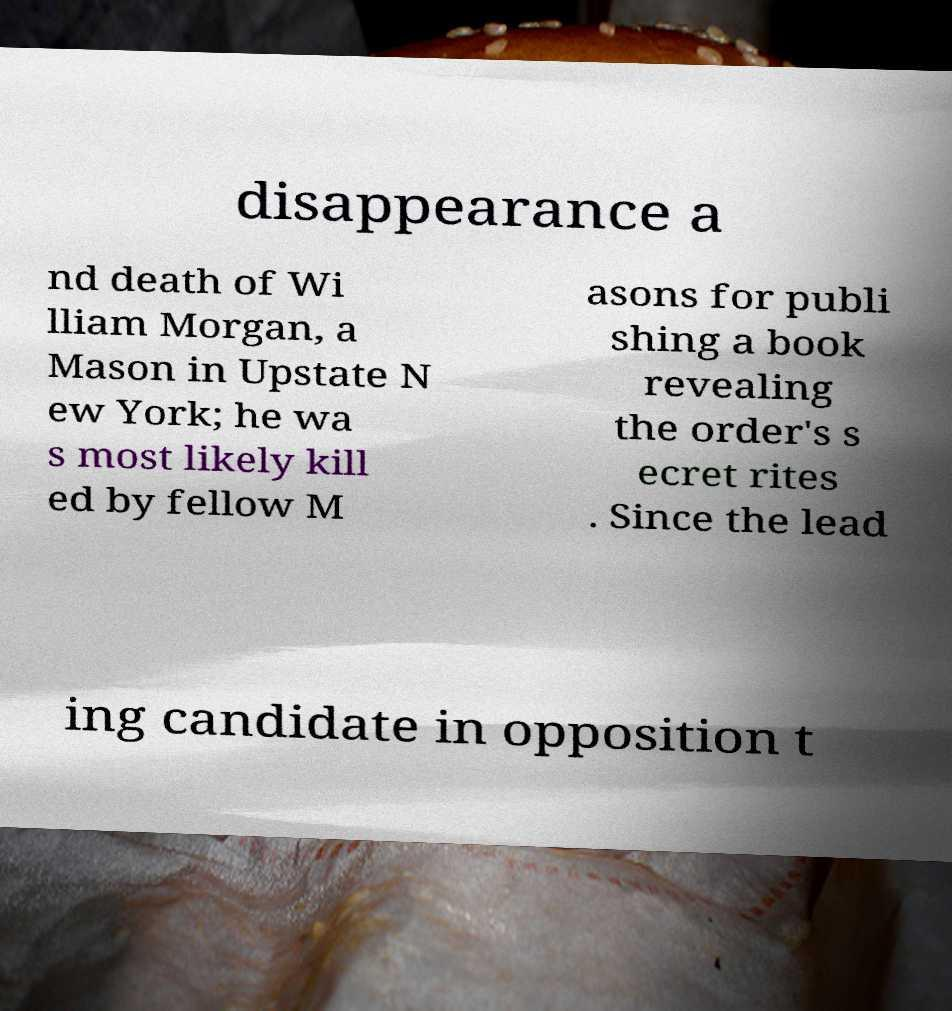For documentation purposes, I need the text within this image transcribed. Could you provide that? disappearance a nd death of Wi lliam Morgan, a Mason in Upstate N ew York; he wa s most likely kill ed by fellow M asons for publi shing a book revealing the order's s ecret rites . Since the lead ing candidate in opposition t 